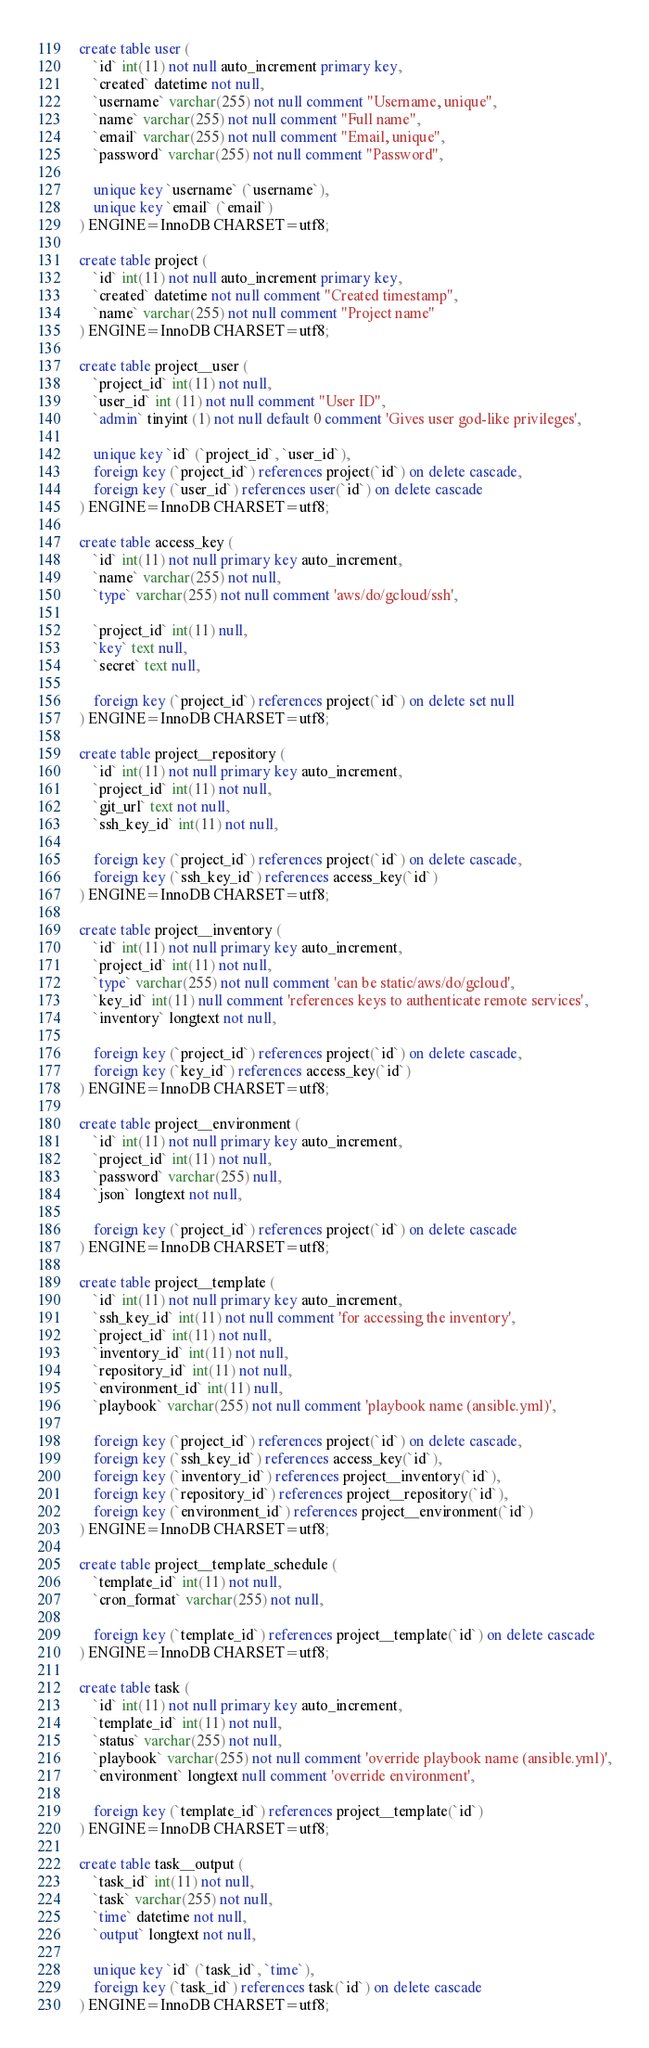<code> <loc_0><loc_0><loc_500><loc_500><_SQL_>create table user (
	`id` int(11) not null auto_increment primary key,
	`created` datetime not null,
	`username` varchar(255) not null comment "Username, unique",
	`name` varchar(255) not null comment "Full name",
	`email` varchar(255) not null comment "Email, unique",
	`password` varchar(255) not null comment "Password",

	unique key `username` (`username`),
	unique key `email` (`email`)
) ENGINE=InnoDB CHARSET=utf8;

create table project (
	`id` int(11) not null auto_increment primary key,
	`created` datetime not null comment "Created timestamp",
	`name` varchar(255) not null comment "Project name"
) ENGINE=InnoDB CHARSET=utf8;

create table project__user (
	`project_id` int(11) not null,
	`user_id` int (11) not null comment "User ID",
	`admin` tinyint (1) not null default 0 comment 'Gives user god-like privileges',

	unique key `id` (`project_id`, `user_id`),
	foreign key (`project_id`) references project(`id`) on delete cascade,
	foreign key (`user_id`) references user(`id`) on delete cascade
) ENGINE=InnoDB CHARSET=utf8;

create table access_key (
	`id` int(11) not null primary key auto_increment,
	`name` varchar(255) not null,
	`type` varchar(255) not null comment 'aws/do/gcloud/ssh',

	`project_id` int(11) null,
	`key` text null,
	`secret` text null,

	foreign key (`project_id`) references project(`id`) on delete set null
) ENGINE=InnoDB CHARSET=utf8;

create table project__repository (
	`id` int(11) not null primary key auto_increment,
	`project_id` int(11) not null,
	`git_url` text not null,
	`ssh_key_id` int(11) not null,

	foreign key (`project_id`) references project(`id`) on delete cascade,
	foreign key (`ssh_key_id`) references access_key(`id`)
) ENGINE=InnoDB CHARSET=utf8;

create table project__inventory (
	`id` int(11) not null primary key auto_increment,
	`project_id` int(11) not null,
	`type` varchar(255) not null comment 'can be static/aws/do/gcloud',
	`key_id` int(11) null comment 'references keys to authenticate remote services',
	`inventory` longtext not null,

	foreign key (`project_id`) references project(`id`) on delete cascade,
	foreign key (`key_id`) references access_key(`id`)
) ENGINE=InnoDB CHARSET=utf8;

create table project__environment (
	`id` int(11) not null primary key auto_increment,
	`project_id` int(11) not null,
	`password` varchar(255) null,
	`json` longtext not null,

	foreign key (`project_id`) references project(`id`) on delete cascade
) ENGINE=InnoDB CHARSET=utf8;

create table project__template (
	`id` int(11) not null primary key auto_increment,
	`ssh_key_id` int(11) not null comment 'for accessing the inventory',
	`project_id` int(11) not null,
	`inventory_id` int(11) not null,
	`repository_id` int(11) not null,
	`environment_id` int(11) null,
	`playbook` varchar(255) not null comment 'playbook name (ansible.yml)',

	foreign key (`project_id`) references project(`id`) on delete cascade,
	foreign key (`ssh_key_id`) references access_key(`id`),
	foreign key (`inventory_id`) references project__inventory(`id`),
	foreign key (`repository_id`) references project__repository(`id`),
	foreign key (`environment_id`) references project__environment(`id`)
) ENGINE=InnoDB CHARSET=utf8;

create table project__template_schedule (
	`template_id` int(11) not null,
	`cron_format` varchar(255) not null,

	foreign key (`template_id`) references project__template(`id`) on delete cascade
) ENGINE=InnoDB CHARSET=utf8;

create table task (
	`id` int(11) not null primary key auto_increment,
	`template_id` int(11) not null,
	`status` varchar(255) not null,
	`playbook` varchar(255) not null comment 'override playbook name (ansible.yml)',
	`environment` longtext null comment 'override environment',

	foreign key (`template_id`) references project__template(`id`)
) ENGINE=InnoDB CHARSET=utf8;

create table task__output (
	`task_id` int(11) not null,
	`task` varchar(255) not null,
	`time` datetime not null,
	`output` longtext not null,

	unique key `id` (`task_id`, `time`),
	foreign key (`task_id`) references task(`id`) on delete cascade
) ENGINE=InnoDB CHARSET=utf8;</code> 